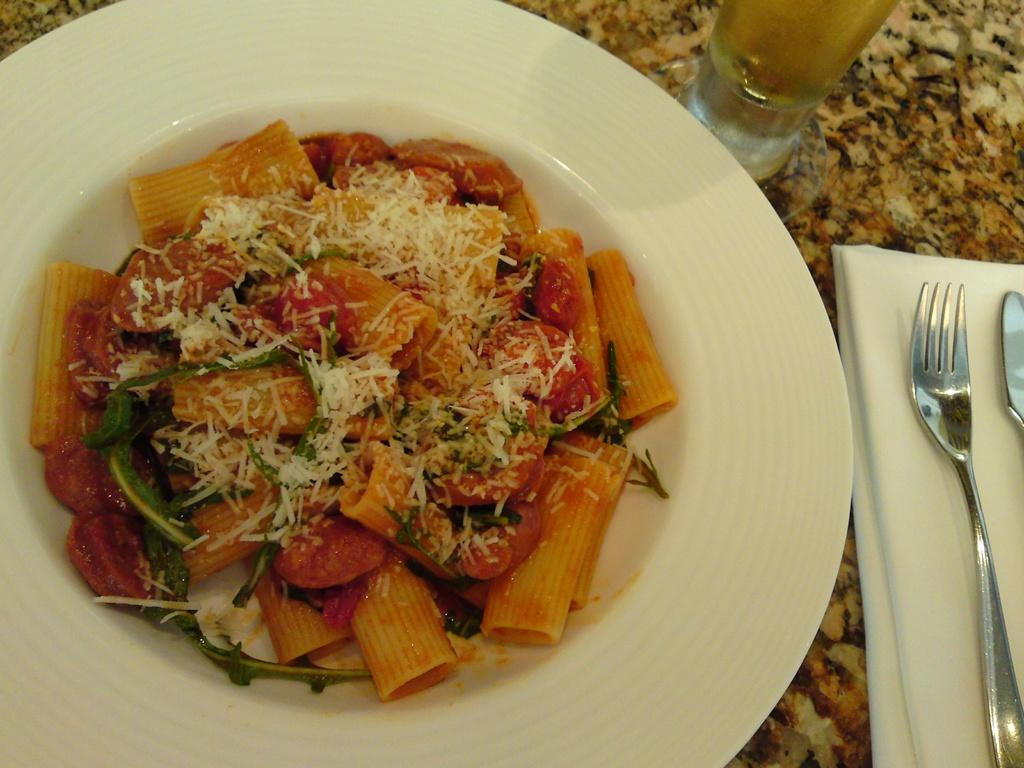What is the main food item in the image? There is a food item in a plate in the center of the image. What utensils are present in the image? There is a fork and spoon on the right side of the image. What can be used for wiping or blowing one's nose in the image? There is a tissue on the right side of the image. What is the container for a beverage in the image? There is a glass on the table. How many thumbs can be seen moving the food item in the image? There are no thumbs or movement of the food item visible in the image. 